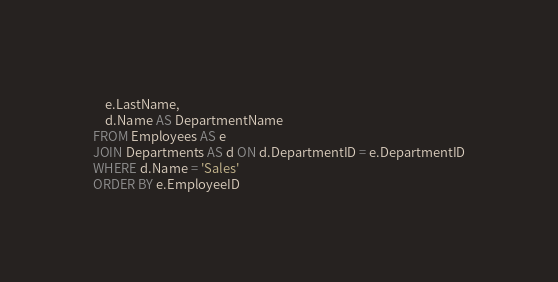<code> <loc_0><loc_0><loc_500><loc_500><_SQL_>	e.LastName,
	d.Name AS DepartmentName
FROM Employees AS e
JOIN Departments AS d ON d.DepartmentID = e.DepartmentID
WHERE d.Name = 'Sales'
ORDER BY e.EmployeeID</code> 